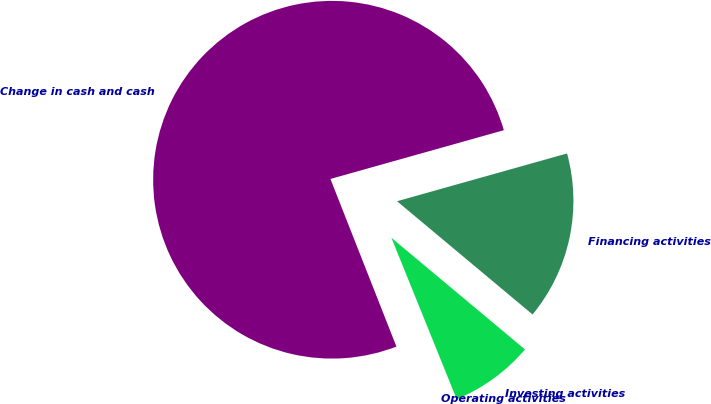Convert chart. <chart><loc_0><loc_0><loc_500><loc_500><pie_chart><fcel>Operating activities<fcel>Investing activities<fcel>Financing activities<fcel>Change in cash and cash<nl><fcel>0.15%<fcel>7.8%<fcel>15.44%<fcel>76.61%<nl></chart> 